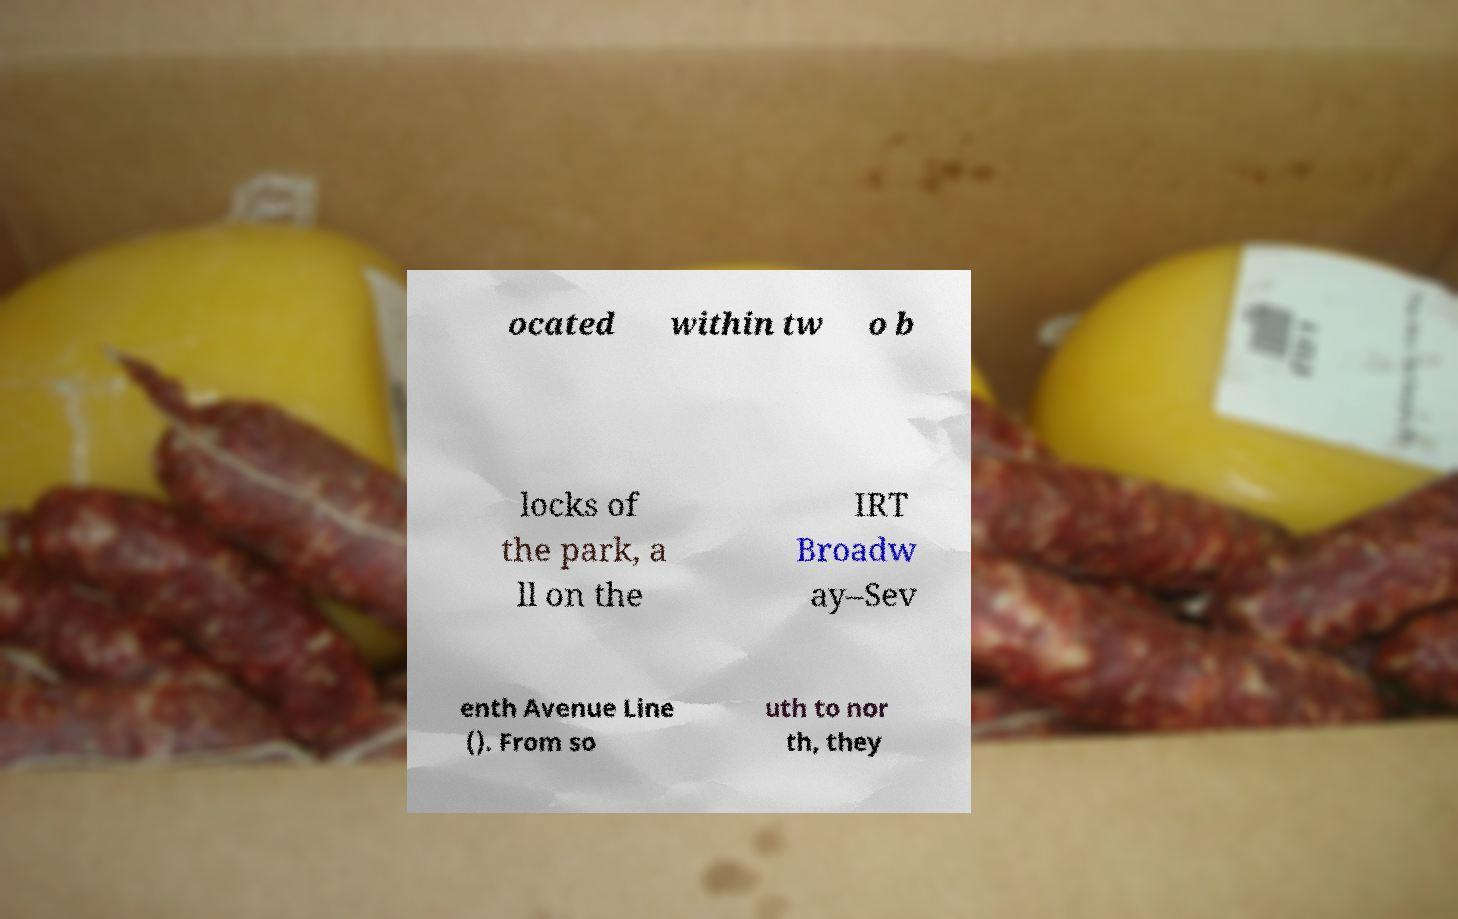Please read and relay the text visible in this image. What does it say? ocated within tw o b locks of the park, a ll on the IRT Broadw ay–Sev enth Avenue Line (). From so uth to nor th, they 